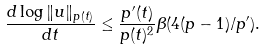Convert formula to latex. <formula><loc_0><loc_0><loc_500><loc_500>\frac { d \log \| u \| _ { p ( t ) } } { d t } \leq \frac { p ^ { \prime } ( t ) } { p ( t ) ^ { 2 } } \beta ( 4 ( p - 1 ) / p ^ { \prime } ) .</formula> 